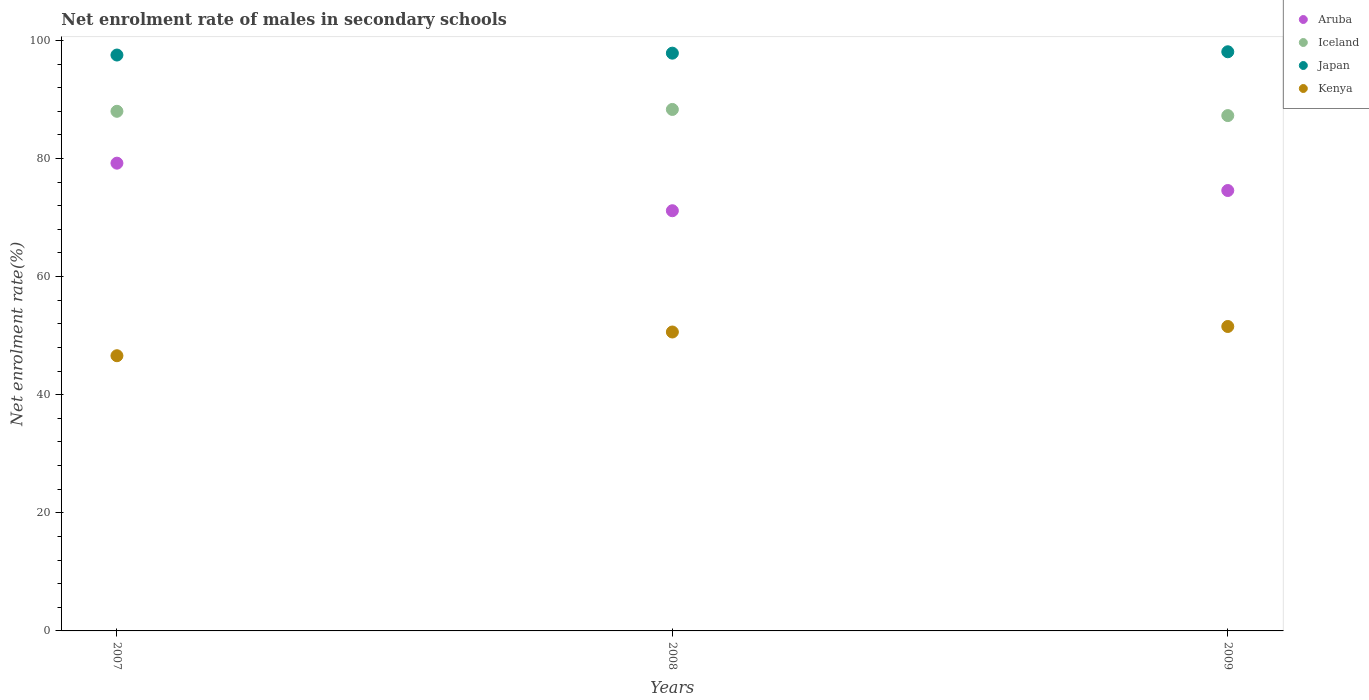Is the number of dotlines equal to the number of legend labels?
Offer a terse response. Yes. What is the net enrolment rate of males in secondary schools in Kenya in 2008?
Make the answer very short. 50.62. Across all years, what is the maximum net enrolment rate of males in secondary schools in Iceland?
Make the answer very short. 88.31. Across all years, what is the minimum net enrolment rate of males in secondary schools in Kenya?
Offer a terse response. 46.6. In which year was the net enrolment rate of males in secondary schools in Japan maximum?
Offer a very short reply. 2009. In which year was the net enrolment rate of males in secondary schools in Iceland minimum?
Give a very brief answer. 2009. What is the total net enrolment rate of males in secondary schools in Kenya in the graph?
Make the answer very short. 148.77. What is the difference between the net enrolment rate of males in secondary schools in Kenya in 2008 and that in 2009?
Offer a terse response. -0.93. What is the difference between the net enrolment rate of males in secondary schools in Iceland in 2007 and the net enrolment rate of males in secondary schools in Kenya in 2008?
Make the answer very short. 37.37. What is the average net enrolment rate of males in secondary schools in Iceland per year?
Your answer should be compact. 87.85. In the year 2008, what is the difference between the net enrolment rate of males in secondary schools in Aruba and net enrolment rate of males in secondary schools in Iceland?
Give a very brief answer. -17.15. What is the ratio of the net enrolment rate of males in secondary schools in Aruba in 2007 to that in 2009?
Your answer should be very brief. 1.06. Is the net enrolment rate of males in secondary schools in Iceland in 2007 less than that in 2008?
Make the answer very short. Yes. What is the difference between the highest and the second highest net enrolment rate of males in secondary schools in Iceland?
Offer a very short reply. 0.31. What is the difference between the highest and the lowest net enrolment rate of males in secondary schools in Iceland?
Give a very brief answer. 1.04. Is it the case that in every year, the sum of the net enrolment rate of males in secondary schools in Kenya and net enrolment rate of males in secondary schools in Japan  is greater than the net enrolment rate of males in secondary schools in Iceland?
Offer a very short reply. Yes. Does the net enrolment rate of males in secondary schools in Iceland monotonically increase over the years?
Offer a terse response. No. Is the net enrolment rate of males in secondary schools in Kenya strictly less than the net enrolment rate of males in secondary schools in Iceland over the years?
Provide a succinct answer. Yes. Are the values on the major ticks of Y-axis written in scientific E-notation?
Provide a short and direct response. No. Where does the legend appear in the graph?
Make the answer very short. Top right. What is the title of the graph?
Your answer should be very brief. Net enrolment rate of males in secondary schools. What is the label or title of the Y-axis?
Ensure brevity in your answer.  Net enrolment rate(%). What is the Net enrolment rate(%) of Aruba in 2007?
Your answer should be very brief. 79.21. What is the Net enrolment rate(%) of Iceland in 2007?
Make the answer very short. 87.99. What is the Net enrolment rate(%) in Japan in 2007?
Provide a succinct answer. 97.52. What is the Net enrolment rate(%) of Kenya in 2007?
Provide a succinct answer. 46.6. What is the Net enrolment rate(%) of Aruba in 2008?
Your answer should be compact. 71.16. What is the Net enrolment rate(%) in Iceland in 2008?
Ensure brevity in your answer.  88.31. What is the Net enrolment rate(%) in Japan in 2008?
Offer a very short reply. 97.84. What is the Net enrolment rate(%) in Kenya in 2008?
Your response must be concise. 50.62. What is the Net enrolment rate(%) in Aruba in 2009?
Make the answer very short. 74.58. What is the Net enrolment rate(%) in Iceland in 2009?
Your response must be concise. 87.26. What is the Net enrolment rate(%) in Japan in 2009?
Make the answer very short. 98.07. What is the Net enrolment rate(%) in Kenya in 2009?
Make the answer very short. 51.55. Across all years, what is the maximum Net enrolment rate(%) in Aruba?
Your answer should be very brief. 79.21. Across all years, what is the maximum Net enrolment rate(%) of Iceland?
Give a very brief answer. 88.31. Across all years, what is the maximum Net enrolment rate(%) of Japan?
Your answer should be compact. 98.07. Across all years, what is the maximum Net enrolment rate(%) of Kenya?
Offer a very short reply. 51.55. Across all years, what is the minimum Net enrolment rate(%) of Aruba?
Keep it short and to the point. 71.16. Across all years, what is the minimum Net enrolment rate(%) of Iceland?
Provide a succinct answer. 87.26. Across all years, what is the minimum Net enrolment rate(%) of Japan?
Provide a succinct answer. 97.52. Across all years, what is the minimum Net enrolment rate(%) in Kenya?
Your response must be concise. 46.6. What is the total Net enrolment rate(%) of Aruba in the graph?
Give a very brief answer. 224.94. What is the total Net enrolment rate(%) of Iceland in the graph?
Your answer should be compact. 263.56. What is the total Net enrolment rate(%) in Japan in the graph?
Ensure brevity in your answer.  293.43. What is the total Net enrolment rate(%) of Kenya in the graph?
Ensure brevity in your answer.  148.77. What is the difference between the Net enrolment rate(%) in Aruba in 2007 and that in 2008?
Your response must be concise. 8.05. What is the difference between the Net enrolment rate(%) in Iceland in 2007 and that in 2008?
Your answer should be very brief. -0.31. What is the difference between the Net enrolment rate(%) in Japan in 2007 and that in 2008?
Give a very brief answer. -0.32. What is the difference between the Net enrolment rate(%) of Kenya in 2007 and that in 2008?
Provide a short and direct response. -4.02. What is the difference between the Net enrolment rate(%) in Aruba in 2007 and that in 2009?
Offer a very short reply. 4.63. What is the difference between the Net enrolment rate(%) in Iceland in 2007 and that in 2009?
Offer a very short reply. 0.73. What is the difference between the Net enrolment rate(%) of Japan in 2007 and that in 2009?
Give a very brief answer. -0.55. What is the difference between the Net enrolment rate(%) in Kenya in 2007 and that in 2009?
Keep it short and to the point. -4.95. What is the difference between the Net enrolment rate(%) in Aruba in 2008 and that in 2009?
Offer a very short reply. -3.42. What is the difference between the Net enrolment rate(%) in Iceland in 2008 and that in 2009?
Provide a succinct answer. 1.04. What is the difference between the Net enrolment rate(%) in Japan in 2008 and that in 2009?
Ensure brevity in your answer.  -0.24. What is the difference between the Net enrolment rate(%) in Kenya in 2008 and that in 2009?
Offer a very short reply. -0.93. What is the difference between the Net enrolment rate(%) of Aruba in 2007 and the Net enrolment rate(%) of Iceland in 2008?
Provide a succinct answer. -9.1. What is the difference between the Net enrolment rate(%) of Aruba in 2007 and the Net enrolment rate(%) of Japan in 2008?
Provide a short and direct response. -18.63. What is the difference between the Net enrolment rate(%) of Aruba in 2007 and the Net enrolment rate(%) of Kenya in 2008?
Provide a short and direct response. 28.59. What is the difference between the Net enrolment rate(%) in Iceland in 2007 and the Net enrolment rate(%) in Japan in 2008?
Your answer should be very brief. -9.84. What is the difference between the Net enrolment rate(%) in Iceland in 2007 and the Net enrolment rate(%) in Kenya in 2008?
Offer a very short reply. 37.37. What is the difference between the Net enrolment rate(%) of Japan in 2007 and the Net enrolment rate(%) of Kenya in 2008?
Give a very brief answer. 46.9. What is the difference between the Net enrolment rate(%) of Aruba in 2007 and the Net enrolment rate(%) of Iceland in 2009?
Offer a very short reply. -8.06. What is the difference between the Net enrolment rate(%) of Aruba in 2007 and the Net enrolment rate(%) of Japan in 2009?
Make the answer very short. -18.86. What is the difference between the Net enrolment rate(%) in Aruba in 2007 and the Net enrolment rate(%) in Kenya in 2009?
Ensure brevity in your answer.  27.66. What is the difference between the Net enrolment rate(%) of Iceland in 2007 and the Net enrolment rate(%) of Japan in 2009?
Your answer should be very brief. -10.08. What is the difference between the Net enrolment rate(%) of Iceland in 2007 and the Net enrolment rate(%) of Kenya in 2009?
Offer a very short reply. 36.44. What is the difference between the Net enrolment rate(%) in Japan in 2007 and the Net enrolment rate(%) in Kenya in 2009?
Give a very brief answer. 45.97. What is the difference between the Net enrolment rate(%) of Aruba in 2008 and the Net enrolment rate(%) of Iceland in 2009?
Your answer should be compact. -16.11. What is the difference between the Net enrolment rate(%) in Aruba in 2008 and the Net enrolment rate(%) in Japan in 2009?
Your answer should be very brief. -26.92. What is the difference between the Net enrolment rate(%) of Aruba in 2008 and the Net enrolment rate(%) of Kenya in 2009?
Offer a very short reply. 19.6. What is the difference between the Net enrolment rate(%) in Iceland in 2008 and the Net enrolment rate(%) in Japan in 2009?
Provide a short and direct response. -9.77. What is the difference between the Net enrolment rate(%) of Iceland in 2008 and the Net enrolment rate(%) of Kenya in 2009?
Offer a very short reply. 36.75. What is the difference between the Net enrolment rate(%) in Japan in 2008 and the Net enrolment rate(%) in Kenya in 2009?
Your answer should be very brief. 46.28. What is the average Net enrolment rate(%) of Aruba per year?
Ensure brevity in your answer.  74.98. What is the average Net enrolment rate(%) in Iceland per year?
Your response must be concise. 87.85. What is the average Net enrolment rate(%) of Japan per year?
Ensure brevity in your answer.  97.81. What is the average Net enrolment rate(%) of Kenya per year?
Give a very brief answer. 49.59. In the year 2007, what is the difference between the Net enrolment rate(%) in Aruba and Net enrolment rate(%) in Iceland?
Give a very brief answer. -8.78. In the year 2007, what is the difference between the Net enrolment rate(%) of Aruba and Net enrolment rate(%) of Japan?
Offer a terse response. -18.31. In the year 2007, what is the difference between the Net enrolment rate(%) of Aruba and Net enrolment rate(%) of Kenya?
Your response must be concise. 32.61. In the year 2007, what is the difference between the Net enrolment rate(%) in Iceland and Net enrolment rate(%) in Japan?
Offer a terse response. -9.53. In the year 2007, what is the difference between the Net enrolment rate(%) of Iceland and Net enrolment rate(%) of Kenya?
Give a very brief answer. 41.39. In the year 2007, what is the difference between the Net enrolment rate(%) of Japan and Net enrolment rate(%) of Kenya?
Ensure brevity in your answer.  50.92. In the year 2008, what is the difference between the Net enrolment rate(%) of Aruba and Net enrolment rate(%) of Iceland?
Ensure brevity in your answer.  -17.15. In the year 2008, what is the difference between the Net enrolment rate(%) in Aruba and Net enrolment rate(%) in Japan?
Your response must be concise. -26.68. In the year 2008, what is the difference between the Net enrolment rate(%) in Aruba and Net enrolment rate(%) in Kenya?
Provide a short and direct response. 20.54. In the year 2008, what is the difference between the Net enrolment rate(%) of Iceland and Net enrolment rate(%) of Japan?
Your answer should be very brief. -9.53. In the year 2008, what is the difference between the Net enrolment rate(%) of Iceland and Net enrolment rate(%) of Kenya?
Keep it short and to the point. 37.69. In the year 2008, what is the difference between the Net enrolment rate(%) in Japan and Net enrolment rate(%) in Kenya?
Provide a succinct answer. 47.22. In the year 2009, what is the difference between the Net enrolment rate(%) of Aruba and Net enrolment rate(%) of Iceland?
Provide a short and direct response. -12.69. In the year 2009, what is the difference between the Net enrolment rate(%) of Aruba and Net enrolment rate(%) of Japan?
Give a very brief answer. -23.49. In the year 2009, what is the difference between the Net enrolment rate(%) of Aruba and Net enrolment rate(%) of Kenya?
Make the answer very short. 23.03. In the year 2009, what is the difference between the Net enrolment rate(%) in Iceland and Net enrolment rate(%) in Japan?
Your answer should be compact. -10.81. In the year 2009, what is the difference between the Net enrolment rate(%) of Iceland and Net enrolment rate(%) of Kenya?
Ensure brevity in your answer.  35.71. In the year 2009, what is the difference between the Net enrolment rate(%) in Japan and Net enrolment rate(%) in Kenya?
Your answer should be compact. 46.52. What is the ratio of the Net enrolment rate(%) in Aruba in 2007 to that in 2008?
Your answer should be very brief. 1.11. What is the ratio of the Net enrolment rate(%) of Kenya in 2007 to that in 2008?
Offer a very short reply. 0.92. What is the ratio of the Net enrolment rate(%) of Aruba in 2007 to that in 2009?
Provide a short and direct response. 1.06. What is the ratio of the Net enrolment rate(%) in Iceland in 2007 to that in 2009?
Ensure brevity in your answer.  1.01. What is the ratio of the Net enrolment rate(%) of Kenya in 2007 to that in 2009?
Provide a short and direct response. 0.9. What is the ratio of the Net enrolment rate(%) in Aruba in 2008 to that in 2009?
Provide a short and direct response. 0.95. What is the ratio of the Net enrolment rate(%) of Iceland in 2008 to that in 2009?
Keep it short and to the point. 1.01. What is the ratio of the Net enrolment rate(%) in Japan in 2008 to that in 2009?
Your response must be concise. 1. What is the ratio of the Net enrolment rate(%) of Kenya in 2008 to that in 2009?
Your answer should be very brief. 0.98. What is the difference between the highest and the second highest Net enrolment rate(%) in Aruba?
Keep it short and to the point. 4.63. What is the difference between the highest and the second highest Net enrolment rate(%) in Iceland?
Keep it short and to the point. 0.31. What is the difference between the highest and the second highest Net enrolment rate(%) of Japan?
Ensure brevity in your answer.  0.24. What is the difference between the highest and the second highest Net enrolment rate(%) in Kenya?
Ensure brevity in your answer.  0.93. What is the difference between the highest and the lowest Net enrolment rate(%) in Aruba?
Your response must be concise. 8.05. What is the difference between the highest and the lowest Net enrolment rate(%) of Iceland?
Make the answer very short. 1.04. What is the difference between the highest and the lowest Net enrolment rate(%) of Japan?
Ensure brevity in your answer.  0.55. What is the difference between the highest and the lowest Net enrolment rate(%) in Kenya?
Provide a short and direct response. 4.95. 